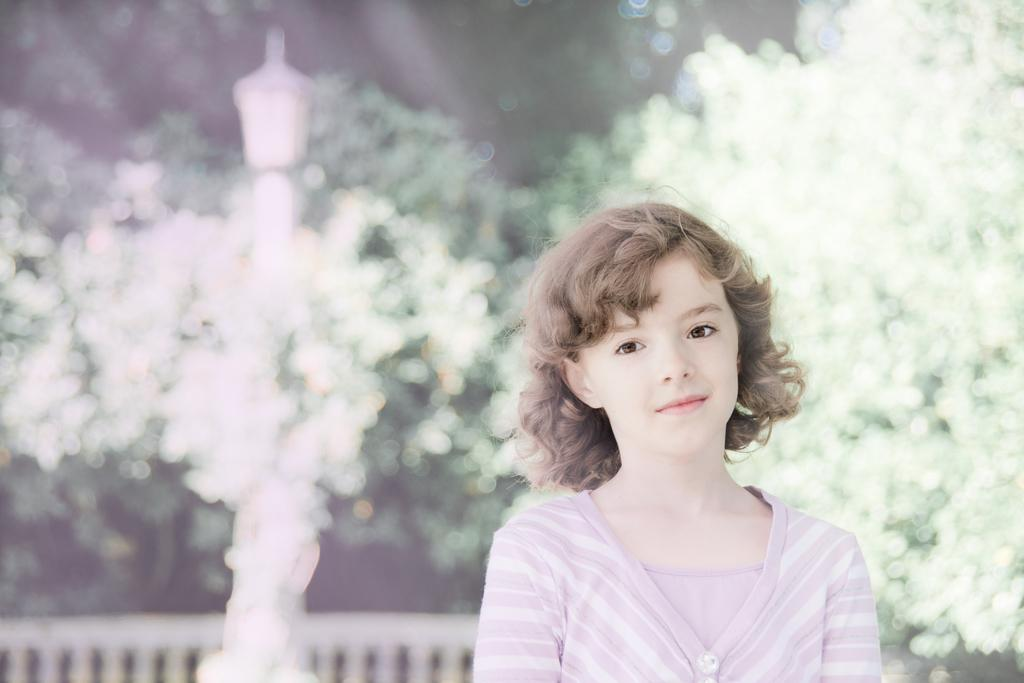Who is the main subject in the image? There is a girl in the center of the image. What is the girl's expression in the image? The girl is smiling in the image. What can be seen in the background of the image? There is a fence, a pole, trees, and a few other objects in the background of the image. What type of soap is the girl using in the image? There is no soap present in the image. What kind of operation is being performed on the girl in the image? There is no operation being performed on the girl in the image. 